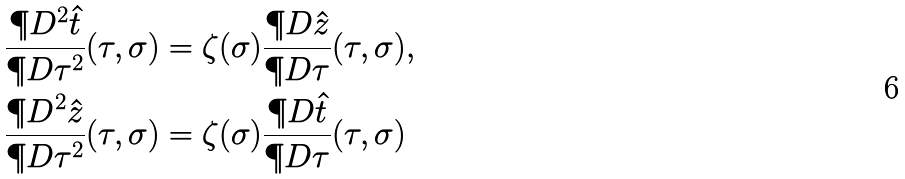<formula> <loc_0><loc_0><loc_500><loc_500>& \frac { \P D ^ { 2 } \hat { t } } { \P D \tau ^ { 2 } } ( \tau , \sigma ) = \zeta ( \sigma ) \frac { \P D \hat { z } } { \P D \tau } ( \tau , \sigma ) , \\ & \frac { \P D ^ { 2 } \hat { z } } { \P D \tau ^ { 2 } } ( \tau , \sigma ) = \zeta ( \sigma ) \frac { \P D \hat { t } } { \P D \tau } ( \tau , \sigma )</formula> 